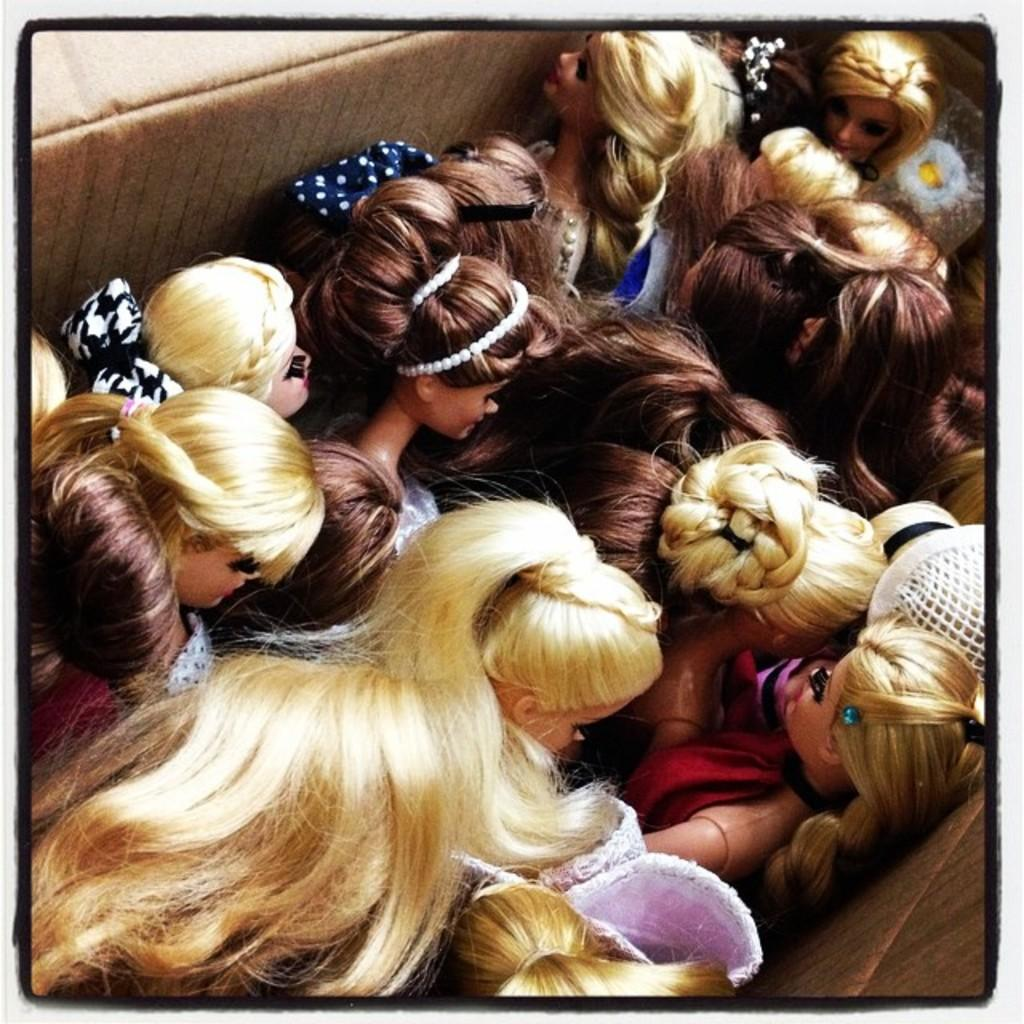What type of toys are present in the image? There are barbie dolls in the image. How are the barbie dolls stored or displayed? The barbie dolls are kept in a box. What can be observed about the appearance of the barbie dolls? The barbie dolls have different types of hairstyles. What type of nest can be seen in the image? There is no nest present in the image; it features barbie dolls in a box. What achievements have the barbie dolls accomplished, as seen in the image? The image does not depict any achievements or accomplishments of the barbie dolls. 